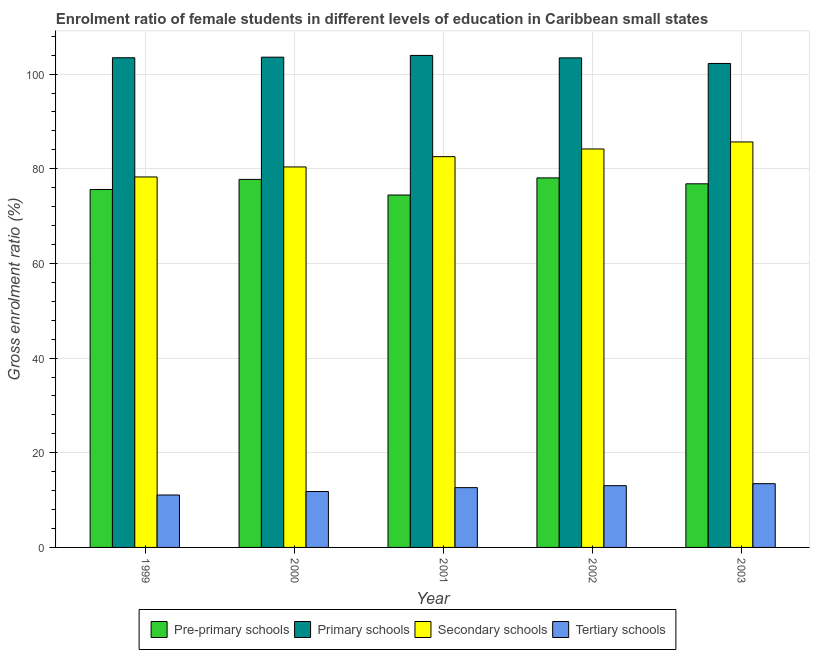How many different coloured bars are there?
Provide a succinct answer. 4. Are the number of bars on each tick of the X-axis equal?
Your answer should be very brief. Yes. How many bars are there on the 3rd tick from the left?
Offer a very short reply. 4. How many bars are there on the 4th tick from the right?
Ensure brevity in your answer.  4. In how many cases, is the number of bars for a given year not equal to the number of legend labels?
Give a very brief answer. 0. What is the gross enrolment ratio(male) in secondary schools in 2000?
Your response must be concise. 80.39. Across all years, what is the maximum gross enrolment ratio(male) in secondary schools?
Your answer should be very brief. 85.67. Across all years, what is the minimum gross enrolment ratio(male) in secondary schools?
Your response must be concise. 78.27. What is the total gross enrolment ratio(male) in tertiary schools in the graph?
Ensure brevity in your answer.  62.04. What is the difference between the gross enrolment ratio(male) in pre-primary schools in 1999 and that in 2003?
Provide a short and direct response. -1.2. What is the difference between the gross enrolment ratio(male) in primary schools in 2002 and the gross enrolment ratio(male) in secondary schools in 2001?
Provide a succinct answer. -0.52. What is the average gross enrolment ratio(male) in primary schools per year?
Provide a short and direct response. 103.34. In the year 2002, what is the difference between the gross enrolment ratio(male) in secondary schools and gross enrolment ratio(male) in pre-primary schools?
Ensure brevity in your answer.  0. What is the ratio of the gross enrolment ratio(male) in primary schools in 1999 to that in 2000?
Give a very brief answer. 1. Is the gross enrolment ratio(male) in tertiary schools in 2000 less than that in 2002?
Offer a very short reply. Yes. Is the difference between the gross enrolment ratio(male) in secondary schools in 1999 and 2002 greater than the difference between the gross enrolment ratio(male) in pre-primary schools in 1999 and 2002?
Give a very brief answer. No. What is the difference between the highest and the second highest gross enrolment ratio(male) in tertiary schools?
Keep it short and to the point. 0.42. What is the difference between the highest and the lowest gross enrolment ratio(male) in pre-primary schools?
Make the answer very short. 3.62. In how many years, is the gross enrolment ratio(male) in tertiary schools greater than the average gross enrolment ratio(male) in tertiary schools taken over all years?
Your answer should be very brief. 3. Is the sum of the gross enrolment ratio(male) in secondary schools in 2001 and 2002 greater than the maximum gross enrolment ratio(male) in pre-primary schools across all years?
Ensure brevity in your answer.  Yes. Is it the case that in every year, the sum of the gross enrolment ratio(male) in primary schools and gross enrolment ratio(male) in secondary schools is greater than the sum of gross enrolment ratio(male) in pre-primary schools and gross enrolment ratio(male) in tertiary schools?
Provide a succinct answer. Yes. What does the 2nd bar from the left in 2001 represents?
Offer a terse response. Primary schools. What does the 2nd bar from the right in 1999 represents?
Your answer should be compact. Secondary schools. Are all the bars in the graph horizontal?
Provide a short and direct response. No. How many years are there in the graph?
Your answer should be compact. 5. Are the values on the major ticks of Y-axis written in scientific E-notation?
Provide a short and direct response. No. Does the graph contain any zero values?
Keep it short and to the point. No. Does the graph contain grids?
Offer a very short reply. Yes. How are the legend labels stacked?
Keep it short and to the point. Horizontal. What is the title of the graph?
Your answer should be compact. Enrolment ratio of female students in different levels of education in Caribbean small states. Does "Social Assistance" appear as one of the legend labels in the graph?
Keep it short and to the point. No. What is the Gross enrolment ratio (%) of Pre-primary schools in 1999?
Ensure brevity in your answer.  75.63. What is the Gross enrolment ratio (%) of Primary schools in 1999?
Offer a terse response. 103.46. What is the Gross enrolment ratio (%) in Secondary schools in 1999?
Make the answer very short. 78.27. What is the Gross enrolment ratio (%) of Tertiary schools in 1999?
Ensure brevity in your answer.  11.07. What is the Gross enrolment ratio (%) in Pre-primary schools in 2000?
Your answer should be very brief. 77.76. What is the Gross enrolment ratio (%) in Primary schools in 2000?
Provide a succinct answer. 103.58. What is the Gross enrolment ratio (%) in Secondary schools in 2000?
Your answer should be compact. 80.39. What is the Gross enrolment ratio (%) of Tertiary schools in 2000?
Make the answer very short. 11.81. What is the Gross enrolment ratio (%) in Pre-primary schools in 2001?
Keep it short and to the point. 74.46. What is the Gross enrolment ratio (%) of Primary schools in 2001?
Provide a short and direct response. 103.95. What is the Gross enrolment ratio (%) in Secondary schools in 2001?
Your answer should be very brief. 82.56. What is the Gross enrolment ratio (%) of Tertiary schools in 2001?
Give a very brief answer. 12.63. What is the Gross enrolment ratio (%) of Pre-primary schools in 2002?
Offer a terse response. 78.08. What is the Gross enrolment ratio (%) of Primary schools in 2002?
Give a very brief answer. 103.44. What is the Gross enrolment ratio (%) in Secondary schools in 2002?
Give a very brief answer. 84.19. What is the Gross enrolment ratio (%) of Tertiary schools in 2002?
Make the answer very short. 13.05. What is the Gross enrolment ratio (%) in Pre-primary schools in 2003?
Provide a succinct answer. 76.83. What is the Gross enrolment ratio (%) in Primary schools in 2003?
Provide a short and direct response. 102.26. What is the Gross enrolment ratio (%) in Secondary schools in 2003?
Keep it short and to the point. 85.67. What is the Gross enrolment ratio (%) in Tertiary schools in 2003?
Keep it short and to the point. 13.47. Across all years, what is the maximum Gross enrolment ratio (%) of Pre-primary schools?
Your answer should be compact. 78.08. Across all years, what is the maximum Gross enrolment ratio (%) of Primary schools?
Offer a terse response. 103.95. Across all years, what is the maximum Gross enrolment ratio (%) of Secondary schools?
Give a very brief answer. 85.67. Across all years, what is the maximum Gross enrolment ratio (%) of Tertiary schools?
Keep it short and to the point. 13.47. Across all years, what is the minimum Gross enrolment ratio (%) of Pre-primary schools?
Make the answer very short. 74.46. Across all years, what is the minimum Gross enrolment ratio (%) of Primary schools?
Provide a succinct answer. 102.26. Across all years, what is the minimum Gross enrolment ratio (%) of Secondary schools?
Give a very brief answer. 78.27. Across all years, what is the minimum Gross enrolment ratio (%) of Tertiary schools?
Keep it short and to the point. 11.07. What is the total Gross enrolment ratio (%) of Pre-primary schools in the graph?
Give a very brief answer. 382.75. What is the total Gross enrolment ratio (%) in Primary schools in the graph?
Give a very brief answer. 516.69. What is the total Gross enrolment ratio (%) of Secondary schools in the graph?
Offer a very short reply. 411.09. What is the total Gross enrolment ratio (%) in Tertiary schools in the graph?
Your answer should be compact. 62.04. What is the difference between the Gross enrolment ratio (%) in Pre-primary schools in 1999 and that in 2000?
Your answer should be very brief. -2.13. What is the difference between the Gross enrolment ratio (%) of Primary schools in 1999 and that in 2000?
Give a very brief answer. -0.12. What is the difference between the Gross enrolment ratio (%) of Secondary schools in 1999 and that in 2000?
Provide a succinct answer. -2.12. What is the difference between the Gross enrolment ratio (%) of Tertiary schools in 1999 and that in 2000?
Give a very brief answer. -0.74. What is the difference between the Gross enrolment ratio (%) of Pre-primary schools in 1999 and that in 2001?
Offer a very short reply. 1.17. What is the difference between the Gross enrolment ratio (%) of Primary schools in 1999 and that in 2001?
Give a very brief answer. -0.49. What is the difference between the Gross enrolment ratio (%) in Secondary schools in 1999 and that in 2001?
Your answer should be compact. -4.29. What is the difference between the Gross enrolment ratio (%) in Tertiary schools in 1999 and that in 2001?
Make the answer very short. -1.56. What is the difference between the Gross enrolment ratio (%) of Pre-primary schools in 1999 and that in 2002?
Your response must be concise. -2.45. What is the difference between the Gross enrolment ratio (%) in Primary schools in 1999 and that in 2002?
Offer a very short reply. 0.02. What is the difference between the Gross enrolment ratio (%) in Secondary schools in 1999 and that in 2002?
Give a very brief answer. -5.91. What is the difference between the Gross enrolment ratio (%) of Tertiary schools in 1999 and that in 2002?
Your answer should be compact. -1.97. What is the difference between the Gross enrolment ratio (%) of Pre-primary schools in 1999 and that in 2003?
Your response must be concise. -1.2. What is the difference between the Gross enrolment ratio (%) of Primary schools in 1999 and that in 2003?
Ensure brevity in your answer.  1.2. What is the difference between the Gross enrolment ratio (%) of Secondary schools in 1999 and that in 2003?
Ensure brevity in your answer.  -7.4. What is the difference between the Gross enrolment ratio (%) in Tertiary schools in 1999 and that in 2003?
Make the answer very short. -2.39. What is the difference between the Gross enrolment ratio (%) in Pre-primary schools in 2000 and that in 2001?
Your response must be concise. 3.3. What is the difference between the Gross enrolment ratio (%) of Primary schools in 2000 and that in 2001?
Your answer should be very brief. -0.37. What is the difference between the Gross enrolment ratio (%) in Secondary schools in 2000 and that in 2001?
Your answer should be compact. -2.17. What is the difference between the Gross enrolment ratio (%) of Tertiary schools in 2000 and that in 2001?
Offer a terse response. -0.82. What is the difference between the Gross enrolment ratio (%) of Pre-primary schools in 2000 and that in 2002?
Ensure brevity in your answer.  -0.32. What is the difference between the Gross enrolment ratio (%) of Primary schools in 2000 and that in 2002?
Your response must be concise. 0.15. What is the difference between the Gross enrolment ratio (%) in Secondary schools in 2000 and that in 2002?
Provide a short and direct response. -3.79. What is the difference between the Gross enrolment ratio (%) of Tertiary schools in 2000 and that in 2002?
Your response must be concise. -1.23. What is the difference between the Gross enrolment ratio (%) in Pre-primary schools in 2000 and that in 2003?
Offer a terse response. 0.93. What is the difference between the Gross enrolment ratio (%) in Primary schools in 2000 and that in 2003?
Ensure brevity in your answer.  1.33. What is the difference between the Gross enrolment ratio (%) in Secondary schools in 2000 and that in 2003?
Offer a very short reply. -5.28. What is the difference between the Gross enrolment ratio (%) in Tertiary schools in 2000 and that in 2003?
Ensure brevity in your answer.  -1.66. What is the difference between the Gross enrolment ratio (%) in Pre-primary schools in 2001 and that in 2002?
Keep it short and to the point. -3.62. What is the difference between the Gross enrolment ratio (%) of Primary schools in 2001 and that in 2002?
Ensure brevity in your answer.  0.52. What is the difference between the Gross enrolment ratio (%) in Secondary schools in 2001 and that in 2002?
Your answer should be very brief. -1.62. What is the difference between the Gross enrolment ratio (%) of Tertiary schools in 2001 and that in 2002?
Keep it short and to the point. -0.42. What is the difference between the Gross enrolment ratio (%) in Pre-primary schools in 2001 and that in 2003?
Offer a terse response. -2.37. What is the difference between the Gross enrolment ratio (%) of Primary schools in 2001 and that in 2003?
Offer a very short reply. 1.7. What is the difference between the Gross enrolment ratio (%) in Secondary schools in 2001 and that in 2003?
Provide a succinct answer. -3.11. What is the difference between the Gross enrolment ratio (%) in Tertiary schools in 2001 and that in 2003?
Make the answer very short. -0.84. What is the difference between the Gross enrolment ratio (%) in Pre-primary schools in 2002 and that in 2003?
Ensure brevity in your answer.  1.25. What is the difference between the Gross enrolment ratio (%) in Primary schools in 2002 and that in 2003?
Ensure brevity in your answer.  1.18. What is the difference between the Gross enrolment ratio (%) of Secondary schools in 2002 and that in 2003?
Offer a very short reply. -1.49. What is the difference between the Gross enrolment ratio (%) in Tertiary schools in 2002 and that in 2003?
Provide a short and direct response. -0.42. What is the difference between the Gross enrolment ratio (%) in Pre-primary schools in 1999 and the Gross enrolment ratio (%) in Primary schools in 2000?
Offer a very short reply. -27.96. What is the difference between the Gross enrolment ratio (%) in Pre-primary schools in 1999 and the Gross enrolment ratio (%) in Secondary schools in 2000?
Provide a short and direct response. -4.76. What is the difference between the Gross enrolment ratio (%) in Pre-primary schools in 1999 and the Gross enrolment ratio (%) in Tertiary schools in 2000?
Offer a terse response. 63.81. What is the difference between the Gross enrolment ratio (%) of Primary schools in 1999 and the Gross enrolment ratio (%) of Secondary schools in 2000?
Provide a short and direct response. 23.07. What is the difference between the Gross enrolment ratio (%) of Primary schools in 1999 and the Gross enrolment ratio (%) of Tertiary schools in 2000?
Your answer should be very brief. 91.65. What is the difference between the Gross enrolment ratio (%) in Secondary schools in 1999 and the Gross enrolment ratio (%) in Tertiary schools in 2000?
Provide a short and direct response. 66.46. What is the difference between the Gross enrolment ratio (%) in Pre-primary schools in 1999 and the Gross enrolment ratio (%) in Primary schools in 2001?
Give a very brief answer. -28.33. What is the difference between the Gross enrolment ratio (%) in Pre-primary schools in 1999 and the Gross enrolment ratio (%) in Secondary schools in 2001?
Your answer should be compact. -6.94. What is the difference between the Gross enrolment ratio (%) in Pre-primary schools in 1999 and the Gross enrolment ratio (%) in Tertiary schools in 2001?
Your answer should be very brief. 62.99. What is the difference between the Gross enrolment ratio (%) in Primary schools in 1999 and the Gross enrolment ratio (%) in Secondary schools in 2001?
Provide a succinct answer. 20.9. What is the difference between the Gross enrolment ratio (%) in Primary schools in 1999 and the Gross enrolment ratio (%) in Tertiary schools in 2001?
Offer a very short reply. 90.83. What is the difference between the Gross enrolment ratio (%) in Secondary schools in 1999 and the Gross enrolment ratio (%) in Tertiary schools in 2001?
Make the answer very short. 65.64. What is the difference between the Gross enrolment ratio (%) of Pre-primary schools in 1999 and the Gross enrolment ratio (%) of Primary schools in 2002?
Provide a short and direct response. -27.81. What is the difference between the Gross enrolment ratio (%) in Pre-primary schools in 1999 and the Gross enrolment ratio (%) in Secondary schools in 2002?
Make the answer very short. -8.56. What is the difference between the Gross enrolment ratio (%) in Pre-primary schools in 1999 and the Gross enrolment ratio (%) in Tertiary schools in 2002?
Offer a very short reply. 62.58. What is the difference between the Gross enrolment ratio (%) in Primary schools in 1999 and the Gross enrolment ratio (%) in Secondary schools in 2002?
Offer a very short reply. 19.27. What is the difference between the Gross enrolment ratio (%) in Primary schools in 1999 and the Gross enrolment ratio (%) in Tertiary schools in 2002?
Provide a short and direct response. 90.41. What is the difference between the Gross enrolment ratio (%) of Secondary schools in 1999 and the Gross enrolment ratio (%) of Tertiary schools in 2002?
Make the answer very short. 65.23. What is the difference between the Gross enrolment ratio (%) of Pre-primary schools in 1999 and the Gross enrolment ratio (%) of Primary schools in 2003?
Offer a terse response. -26.63. What is the difference between the Gross enrolment ratio (%) of Pre-primary schools in 1999 and the Gross enrolment ratio (%) of Secondary schools in 2003?
Offer a very short reply. -10.04. What is the difference between the Gross enrolment ratio (%) in Pre-primary schools in 1999 and the Gross enrolment ratio (%) in Tertiary schools in 2003?
Your response must be concise. 62.16. What is the difference between the Gross enrolment ratio (%) in Primary schools in 1999 and the Gross enrolment ratio (%) in Secondary schools in 2003?
Make the answer very short. 17.79. What is the difference between the Gross enrolment ratio (%) of Primary schools in 1999 and the Gross enrolment ratio (%) of Tertiary schools in 2003?
Give a very brief answer. 89.99. What is the difference between the Gross enrolment ratio (%) in Secondary schools in 1999 and the Gross enrolment ratio (%) in Tertiary schools in 2003?
Keep it short and to the point. 64.81. What is the difference between the Gross enrolment ratio (%) of Pre-primary schools in 2000 and the Gross enrolment ratio (%) of Primary schools in 2001?
Provide a succinct answer. -26.19. What is the difference between the Gross enrolment ratio (%) in Pre-primary schools in 2000 and the Gross enrolment ratio (%) in Secondary schools in 2001?
Keep it short and to the point. -4.8. What is the difference between the Gross enrolment ratio (%) in Pre-primary schools in 2000 and the Gross enrolment ratio (%) in Tertiary schools in 2001?
Provide a succinct answer. 65.13. What is the difference between the Gross enrolment ratio (%) in Primary schools in 2000 and the Gross enrolment ratio (%) in Secondary schools in 2001?
Make the answer very short. 21.02. What is the difference between the Gross enrolment ratio (%) in Primary schools in 2000 and the Gross enrolment ratio (%) in Tertiary schools in 2001?
Provide a short and direct response. 90.95. What is the difference between the Gross enrolment ratio (%) of Secondary schools in 2000 and the Gross enrolment ratio (%) of Tertiary schools in 2001?
Your response must be concise. 67.76. What is the difference between the Gross enrolment ratio (%) of Pre-primary schools in 2000 and the Gross enrolment ratio (%) of Primary schools in 2002?
Your answer should be very brief. -25.68. What is the difference between the Gross enrolment ratio (%) in Pre-primary schools in 2000 and the Gross enrolment ratio (%) in Secondary schools in 2002?
Ensure brevity in your answer.  -6.43. What is the difference between the Gross enrolment ratio (%) in Pre-primary schools in 2000 and the Gross enrolment ratio (%) in Tertiary schools in 2002?
Your response must be concise. 64.71. What is the difference between the Gross enrolment ratio (%) of Primary schools in 2000 and the Gross enrolment ratio (%) of Secondary schools in 2002?
Give a very brief answer. 19.4. What is the difference between the Gross enrolment ratio (%) in Primary schools in 2000 and the Gross enrolment ratio (%) in Tertiary schools in 2002?
Provide a short and direct response. 90.53. What is the difference between the Gross enrolment ratio (%) in Secondary schools in 2000 and the Gross enrolment ratio (%) in Tertiary schools in 2002?
Ensure brevity in your answer.  67.34. What is the difference between the Gross enrolment ratio (%) in Pre-primary schools in 2000 and the Gross enrolment ratio (%) in Primary schools in 2003?
Provide a succinct answer. -24.5. What is the difference between the Gross enrolment ratio (%) in Pre-primary schools in 2000 and the Gross enrolment ratio (%) in Secondary schools in 2003?
Your answer should be very brief. -7.91. What is the difference between the Gross enrolment ratio (%) of Pre-primary schools in 2000 and the Gross enrolment ratio (%) of Tertiary schools in 2003?
Keep it short and to the point. 64.29. What is the difference between the Gross enrolment ratio (%) of Primary schools in 2000 and the Gross enrolment ratio (%) of Secondary schools in 2003?
Provide a succinct answer. 17.91. What is the difference between the Gross enrolment ratio (%) of Primary schools in 2000 and the Gross enrolment ratio (%) of Tertiary schools in 2003?
Ensure brevity in your answer.  90.11. What is the difference between the Gross enrolment ratio (%) in Secondary schools in 2000 and the Gross enrolment ratio (%) in Tertiary schools in 2003?
Ensure brevity in your answer.  66.92. What is the difference between the Gross enrolment ratio (%) in Pre-primary schools in 2001 and the Gross enrolment ratio (%) in Primary schools in 2002?
Make the answer very short. -28.98. What is the difference between the Gross enrolment ratio (%) in Pre-primary schools in 2001 and the Gross enrolment ratio (%) in Secondary schools in 2002?
Your answer should be compact. -9.73. What is the difference between the Gross enrolment ratio (%) of Pre-primary schools in 2001 and the Gross enrolment ratio (%) of Tertiary schools in 2002?
Your answer should be very brief. 61.41. What is the difference between the Gross enrolment ratio (%) in Primary schools in 2001 and the Gross enrolment ratio (%) in Secondary schools in 2002?
Provide a succinct answer. 19.77. What is the difference between the Gross enrolment ratio (%) in Primary schools in 2001 and the Gross enrolment ratio (%) in Tertiary schools in 2002?
Offer a terse response. 90.9. What is the difference between the Gross enrolment ratio (%) in Secondary schools in 2001 and the Gross enrolment ratio (%) in Tertiary schools in 2002?
Offer a terse response. 69.52. What is the difference between the Gross enrolment ratio (%) of Pre-primary schools in 2001 and the Gross enrolment ratio (%) of Primary schools in 2003?
Your response must be concise. -27.8. What is the difference between the Gross enrolment ratio (%) of Pre-primary schools in 2001 and the Gross enrolment ratio (%) of Secondary schools in 2003?
Your answer should be very brief. -11.21. What is the difference between the Gross enrolment ratio (%) of Pre-primary schools in 2001 and the Gross enrolment ratio (%) of Tertiary schools in 2003?
Keep it short and to the point. 60.99. What is the difference between the Gross enrolment ratio (%) in Primary schools in 2001 and the Gross enrolment ratio (%) in Secondary schools in 2003?
Provide a short and direct response. 18.28. What is the difference between the Gross enrolment ratio (%) in Primary schools in 2001 and the Gross enrolment ratio (%) in Tertiary schools in 2003?
Provide a succinct answer. 90.48. What is the difference between the Gross enrolment ratio (%) in Secondary schools in 2001 and the Gross enrolment ratio (%) in Tertiary schools in 2003?
Offer a terse response. 69.09. What is the difference between the Gross enrolment ratio (%) in Pre-primary schools in 2002 and the Gross enrolment ratio (%) in Primary schools in 2003?
Give a very brief answer. -24.18. What is the difference between the Gross enrolment ratio (%) in Pre-primary schools in 2002 and the Gross enrolment ratio (%) in Secondary schools in 2003?
Your answer should be very brief. -7.6. What is the difference between the Gross enrolment ratio (%) of Pre-primary schools in 2002 and the Gross enrolment ratio (%) of Tertiary schools in 2003?
Provide a succinct answer. 64.61. What is the difference between the Gross enrolment ratio (%) of Primary schools in 2002 and the Gross enrolment ratio (%) of Secondary schools in 2003?
Your answer should be very brief. 17.76. What is the difference between the Gross enrolment ratio (%) in Primary schools in 2002 and the Gross enrolment ratio (%) in Tertiary schools in 2003?
Make the answer very short. 89.97. What is the difference between the Gross enrolment ratio (%) in Secondary schools in 2002 and the Gross enrolment ratio (%) in Tertiary schools in 2003?
Provide a short and direct response. 70.72. What is the average Gross enrolment ratio (%) in Pre-primary schools per year?
Your answer should be very brief. 76.55. What is the average Gross enrolment ratio (%) of Primary schools per year?
Provide a short and direct response. 103.34. What is the average Gross enrolment ratio (%) of Secondary schools per year?
Your answer should be very brief. 82.22. What is the average Gross enrolment ratio (%) in Tertiary schools per year?
Your answer should be very brief. 12.41. In the year 1999, what is the difference between the Gross enrolment ratio (%) in Pre-primary schools and Gross enrolment ratio (%) in Primary schools?
Keep it short and to the point. -27.83. In the year 1999, what is the difference between the Gross enrolment ratio (%) in Pre-primary schools and Gross enrolment ratio (%) in Secondary schools?
Your answer should be compact. -2.65. In the year 1999, what is the difference between the Gross enrolment ratio (%) in Pre-primary schools and Gross enrolment ratio (%) in Tertiary schools?
Offer a terse response. 64.55. In the year 1999, what is the difference between the Gross enrolment ratio (%) of Primary schools and Gross enrolment ratio (%) of Secondary schools?
Keep it short and to the point. 25.18. In the year 1999, what is the difference between the Gross enrolment ratio (%) of Primary schools and Gross enrolment ratio (%) of Tertiary schools?
Make the answer very short. 92.39. In the year 1999, what is the difference between the Gross enrolment ratio (%) of Secondary schools and Gross enrolment ratio (%) of Tertiary schools?
Keep it short and to the point. 67.2. In the year 2000, what is the difference between the Gross enrolment ratio (%) of Pre-primary schools and Gross enrolment ratio (%) of Primary schools?
Offer a very short reply. -25.82. In the year 2000, what is the difference between the Gross enrolment ratio (%) in Pre-primary schools and Gross enrolment ratio (%) in Secondary schools?
Provide a succinct answer. -2.63. In the year 2000, what is the difference between the Gross enrolment ratio (%) in Pre-primary schools and Gross enrolment ratio (%) in Tertiary schools?
Ensure brevity in your answer.  65.95. In the year 2000, what is the difference between the Gross enrolment ratio (%) in Primary schools and Gross enrolment ratio (%) in Secondary schools?
Provide a short and direct response. 23.19. In the year 2000, what is the difference between the Gross enrolment ratio (%) in Primary schools and Gross enrolment ratio (%) in Tertiary schools?
Your answer should be very brief. 91.77. In the year 2000, what is the difference between the Gross enrolment ratio (%) in Secondary schools and Gross enrolment ratio (%) in Tertiary schools?
Provide a succinct answer. 68.58. In the year 2001, what is the difference between the Gross enrolment ratio (%) of Pre-primary schools and Gross enrolment ratio (%) of Primary schools?
Offer a very short reply. -29.49. In the year 2001, what is the difference between the Gross enrolment ratio (%) in Pre-primary schools and Gross enrolment ratio (%) in Secondary schools?
Your answer should be very brief. -8.1. In the year 2001, what is the difference between the Gross enrolment ratio (%) in Pre-primary schools and Gross enrolment ratio (%) in Tertiary schools?
Offer a very short reply. 61.83. In the year 2001, what is the difference between the Gross enrolment ratio (%) in Primary schools and Gross enrolment ratio (%) in Secondary schools?
Provide a short and direct response. 21.39. In the year 2001, what is the difference between the Gross enrolment ratio (%) of Primary schools and Gross enrolment ratio (%) of Tertiary schools?
Provide a short and direct response. 91.32. In the year 2001, what is the difference between the Gross enrolment ratio (%) in Secondary schools and Gross enrolment ratio (%) in Tertiary schools?
Provide a succinct answer. 69.93. In the year 2002, what is the difference between the Gross enrolment ratio (%) of Pre-primary schools and Gross enrolment ratio (%) of Primary schools?
Offer a very short reply. -25.36. In the year 2002, what is the difference between the Gross enrolment ratio (%) in Pre-primary schools and Gross enrolment ratio (%) in Secondary schools?
Your answer should be very brief. -6.11. In the year 2002, what is the difference between the Gross enrolment ratio (%) of Pre-primary schools and Gross enrolment ratio (%) of Tertiary schools?
Offer a terse response. 65.03. In the year 2002, what is the difference between the Gross enrolment ratio (%) of Primary schools and Gross enrolment ratio (%) of Secondary schools?
Provide a succinct answer. 19.25. In the year 2002, what is the difference between the Gross enrolment ratio (%) in Primary schools and Gross enrolment ratio (%) in Tertiary schools?
Ensure brevity in your answer.  90.39. In the year 2002, what is the difference between the Gross enrolment ratio (%) in Secondary schools and Gross enrolment ratio (%) in Tertiary schools?
Offer a very short reply. 71.14. In the year 2003, what is the difference between the Gross enrolment ratio (%) in Pre-primary schools and Gross enrolment ratio (%) in Primary schools?
Provide a succinct answer. -25.43. In the year 2003, what is the difference between the Gross enrolment ratio (%) of Pre-primary schools and Gross enrolment ratio (%) of Secondary schools?
Keep it short and to the point. -8.84. In the year 2003, what is the difference between the Gross enrolment ratio (%) of Pre-primary schools and Gross enrolment ratio (%) of Tertiary schools?
Provide a succinct answer. 63.36. In the year 2003, what is the difference between the Gross enrolment ratio (%) in Primary schools and Gross enrolment ratio (%) in Secondary schools?
Your answer should be very brief. 16.58. In the year 2003, what is the difference between the Gross enrolment ratio (%) in Primary schools and Gross enrolment ratio (%) in Tertiary schools?
Make the answer very short. 88.79. In the year 2003, what is the difference between the Gross enrolment ratio (%) of Secondary schools and Gross enrolment ratio (%) of Tertiary schools?
Offer a very short reply. 72.2. What is the ratio of the Gross enrolment ratio (%) in Pre-primary schools in 1999 to that in 2000?
Offer a very short reply. 0.97. What is the ratio of the Gross enrolment ratio (%) in Secondary schools in 1999 to that in 2000?
Make the answer very short. 0.97. What is the ratio of the Gross enrolment ratio (%) in Tertiary schools in 1999 to that in 2000?
Provide a succinct answer. 0.94. What is the ratio of the Gross enrolment ratio (%) in Pre-primary schools in 1999 to that in 2001?
Offer a very short reply. 1.02. What is the ratio of the Gross enrolment ratio (%) of Secondary schools in 1999 to that in 2001?
Your answer should be very brief. 0.95. What is the ratio of the Gross enrolment ratio (%) of Tertiary schools in 1999 to that in 2001?
Your answer should be very brief. 0.88. What is the ratio of the Gross enrolment ratio (%) in Pre-primary schools in 1999 to that in 2002?
Offer a very short reply. 0.97. What is the ratio of the Gross enrolment ratio (%) of Secondary schools in 1999 to that in 2002?
Give a very brief answer. 0.93. What is the ratio of the Gross enrolment ratio (%) in Tertiary schools in 1999 to that in 2002?
Keep it short and to the point. 0.85. What is the ratio of the Gross enrolment ratio (%) of Pre-primary schools in 1999 to that in 2003?
Offer a terse response. 0.98. What is the ratio of the Gross enrolment ratio (%) in Primary schools in 1999 to that in 2003?
Offer a terse response. 1.01. What is the ratio of the Gross enrolment ratio (%) of Secondary schools in 1999 to that in 2003?
Your answer should be compact. 0.91. What is the ratio of the Gross enrolment ratio (%) in Tertiary schools in 1999 to that in 2003?
Your response must be concise. 0.82. What is the ratio of the Gross enrolment ratio (%) of Pre-primary schools in 2000 to that in 2001?
Your answer should be compact. 1.04. What is the ratio of the Gross enrolment ratio (%) of Primary schools in 2000 to that in 2001?
Provide a succinct answer. 1. What is the ratio of the Gross enrolment ratio (%) of Secondary schools in 2000 to that in 2001?
Ensure brevity in your answer.  0.97. What is the ratio of the Gross enrolment ratio (%) in Tertiary schools in 2000 to that in 2001?
Ensure brevity in your answer.  0.94. What is the ratio of the Gross enrolment ratio (%) in Primary schools in 2000 to that in 2002?
Make the answer very short. 1. What is the ratio of the Gross enrolment ratio (%) in Secondary schools in 2000 to that in 2002?
Your answer should be very brief. 0.95. What is the ratio of the Gross enrolment ratio (%) of Tertiary schools in 2000 to that in 2002?
Provide a succinct answer. 0.91. What is the ratio of the Gross enrolment ratio (%) of Pre-primary schools in 2000 to that in 2003?
Ensure brevity in your answer.  1.01. What is the ratio of the Gross enrolment ratio (%) in Primary schools in 2000 to that in 2003?
Your answer should be very brief. 1.01. What is the ratio of the Gross enrolment ratio (%) of Secondary schools in 2000 to that in 2003?
Provide a short and direct response. 0.94. What is the ratio of the Gross enrolment ratio (%) in Tertiary schools in 2000 to that in 2003?
Provide a succinct answer. 0.88. What is the ratio of the Gross enrolment ratio (%) in Pre-primary schools in 2001 to that in 2002?
Offer a very short reply. 0.95. What is the ratio of the Gross enrolment ratio (%) in Secondary schools in 2001 to that in 2002?
Provide a short and direct response. 0.98. What is the ratio of the Gross enrolment ratio (%) in Tertiary schools in 2001 to that in 2002?
Your response must be concise. 0.97. What is the ratio of the Gross enrolment ratio (%) of Pre-primary schools in 2001 to that in 2003?
Keep it short and to the point. 0.97. What is the ratio of the Gross enrolment ratio (%) of Primary schools in 2001 to that in 2003?
Give a very brief answer. 1.02. What is the ratio of the Gross enrolment ratio (%) in Secondary schools in 2001 to that in 2003?
Your response must be concise. 0.96. What is the ratio of the Gross enrolment ratio (%) in Tertiary schools in 2001 to that in 2003?
Provide a succinct answer. 0.94. What is the ratio of the Gross enrolment ratio (%) of Pre-primary schools in 2002 to that in 2003?
Ensure brevity in your answer.  1.02. What is the ratio of the Gross enrolment ratio (%) in Primary schools in 2002 to that in 2003?
Your answer should be very brief. 1.01. What is the ratio of the Gross enrolment ratio (%) in Secondary schools in 2002 to that in 2003?
Provide a short and direct response. 0.98. What is the ratio of the Gross enrolment ratio (%) in Tertiary schools in 2002 to that in 2003?
Ensure brevity in your answer.  0.97. What is the difference between the highest and the second highest Gross enrolment ratio (%) in Pre-primary schools?
Provide a short and direct response. 0.32. What is the difference between the highest and the second highest Gross enrolment ratio (%) in Primary schools?
Your answer should be compact. 0.37. What is the difference between the highest and the second highest Gross enrolment ratio (%) in Secondary schools?
Make the answer very short. 1.49. What is the difference between the highest and the second highest Gross enrolment ratio (%) of Tertiary schools?
Keep it short and to the point. 0.42. What is the difference between the highest and the lowest Gross enrolment ratio (%) in Pre-primary schools?
Your answer should be compact. 3.62. What is the difference between the highest and the lowest Gross enrolment ratio (%) of Primary schools?
Offer a very short reply. 1.7. What is the difference between the highest and the lowest Gross enrolment ratio (%) of Secondary schools?
Keep it short and to the point. 7.4. What is the difference between the highest and the lowest Gross enrolment ratio (%) of Tertiary schools?
Your answer should be very brief. 2.39. 